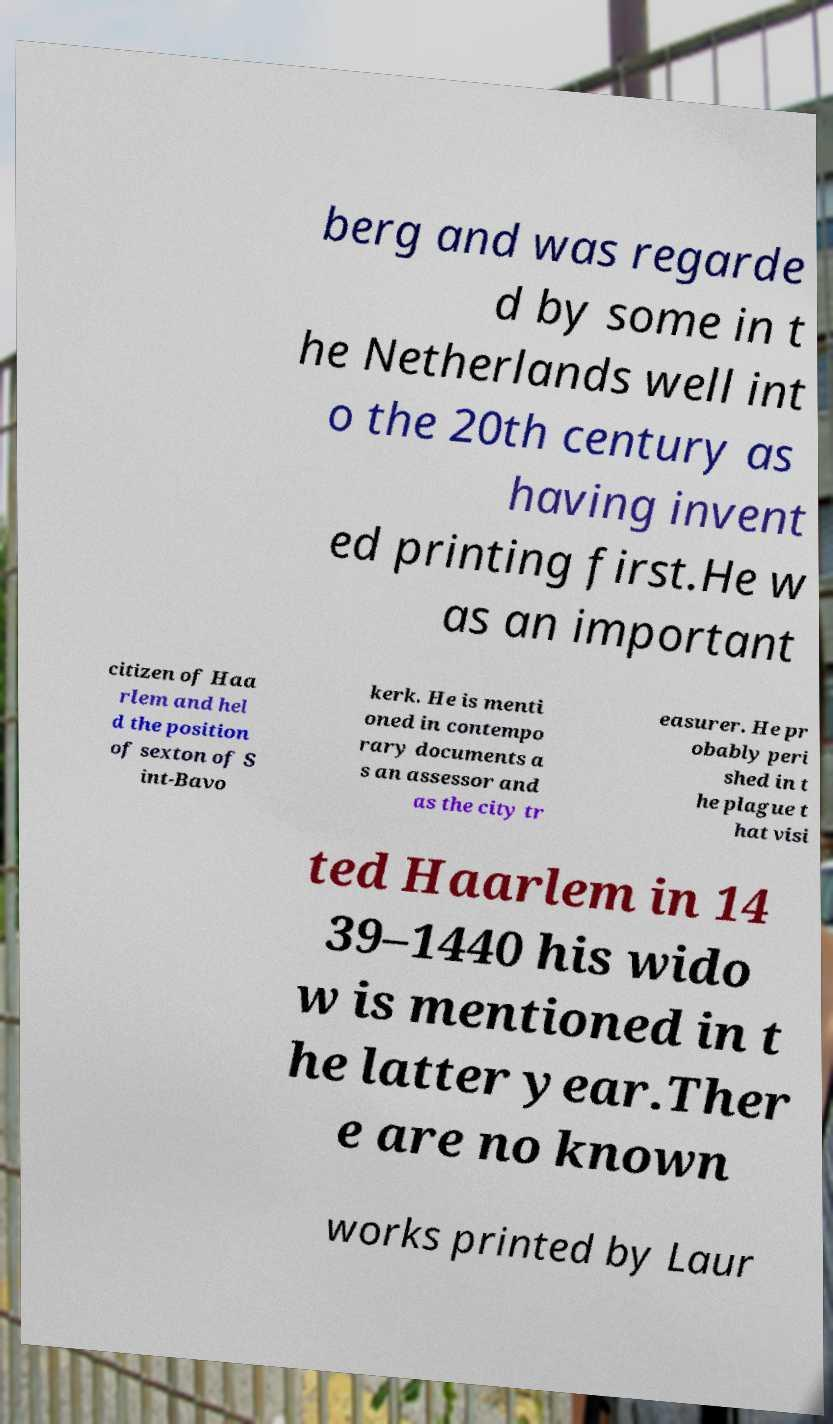Can you accurately transcribe the text from the provided image for me? berg and was regarde d by some in t he Netherlands well int o the 20th century as having invent ed printing first.He w as an important citizen of Haa rlem and hel d the position of sexton of S int-Bavo kerk. He is menti oned in contempo rary documents a s an assessor and as the city tr easurer. He pr obably peri shed in t he plague t hat visi ted Haarlem in 14 39–1440 his wido w is mentioned in t he latter year.Ther e are no known works printed by Laur 